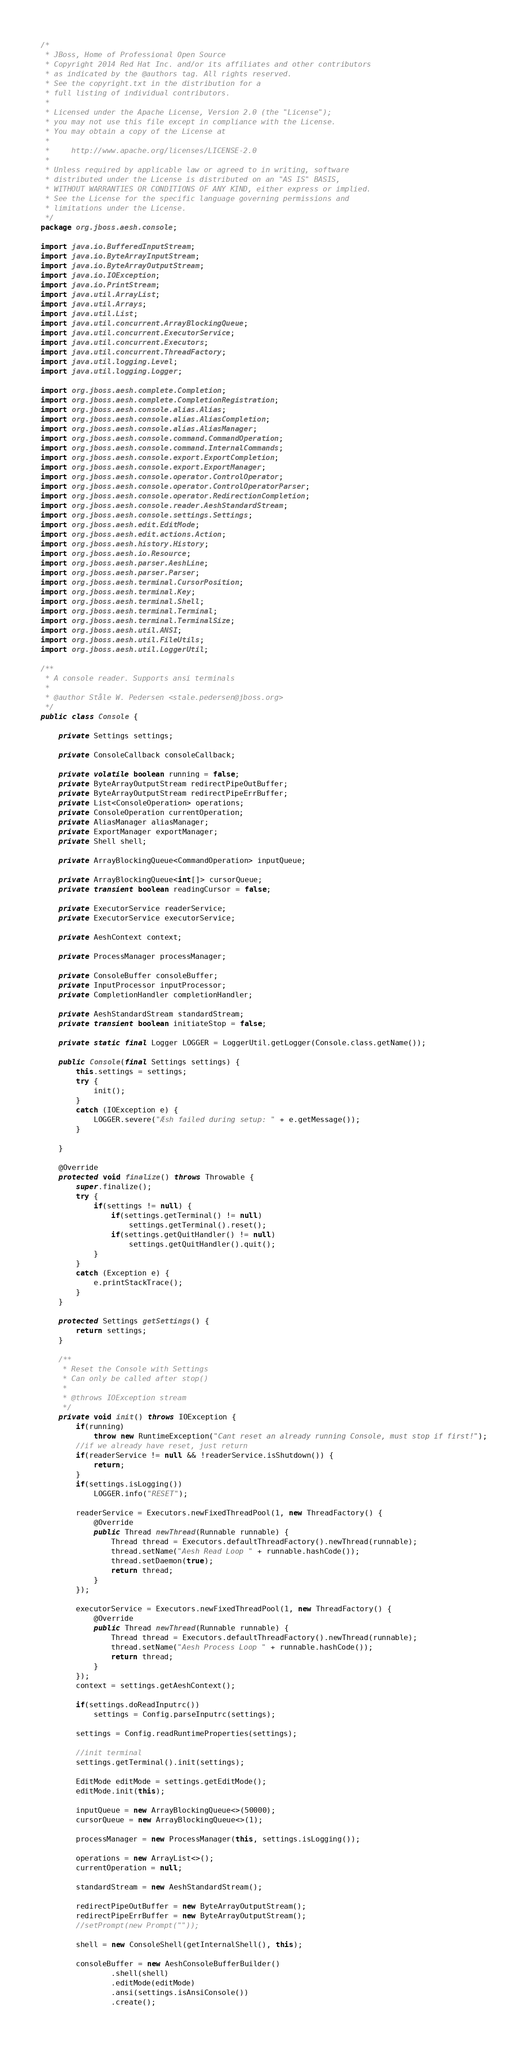<code> <loc_0><loc_0><loc_500><loc_500><_Java_>/*
 * JBoss, Home of Professional Open Source
 * Copyright 2014 Red Hat Inc. and/or its affiliates and other contributors
 * as indicated by the @authors tag. All rights reserved.
 * See the copyright.txt in the distribution for a
 * full listing of individual contributors.
 *
 * Licensed under the Apache License, Version 2.0 (the "License");
 * you may not use this file except in compliance with the License.
 * You may obtain a copy of the License at
 *
 *     http://www.apache.org/licenses/LICENSE-2.0
 *
 * Unless required by applicable law or agreed to in writing, software
 * distributed under the License is distributed on an "AS IS" BASIS,
 * WITHOUT WARRANTIES OR CONDITIONS OF ANY KIND, either express or implied.
 * See the License for the specific language governing permissions and
 * limitations under the License.
 */
package org.jboss.aesh.console;

import java.io.BufferedInputStream;
import java.io.ByteArrayInputStream;
import java.io.ByteArrayOutputStream;
import java.io.IOException;
import java.io.PrintStream;
import java.util.ArrayList;
import java.util.Arrays;
import java.util.List;
import java.util.concurrent.ArrayBlockingQueue;
import java.util.concurrent.ExecutorService;
import java.util.concurrent.Executors;
import java.util.concurrent.ThreadFactory;
import java.util.logging.Level;
import java.util.logging.Logger;

import org.jboss.aesh.complete.Completion;
import org.jboss.aesh.complete.CompletionRegistration;
import org.jboss.aesh.console.alias.Alias;
import org.jboss.aesh.console.alias.AliasCompletion;
import org.jboss.aesh.console.alias.AliasManager;
import org.jboss.aesh.console.command.CommandOperation;
import org.jboss.aesh.console.command.InternalCommands;
import org.jboss.aesh.console.export.ExportCompletion;
import org.jboss.aesh.console.export.ExportManager;
import org.jboss.aesh.console.operator.ControlOperator;
import org.jboss.aesh.console.operator.ControlOperatorParser;
import org.jboss.aesh.console.operator.RedirectionCompletion;
import org.jboss.aesh.console.reader.AeshStandardStream;
import org.jboss.aesh.console.settings.Settings;
import org.jboss.aesh.edit.EditMode;
import org.jboss.aesh.edit.actions.Action;
import org.jboss.aesh.history.History;
import org.jboss.aesh.io.Resource;
import org.jboss.aesh.parser.AeshLine;
import org.jboss.aesh.parser.Parser;
import org.jboss.aesh.terminal.CursorPosition;
import org.jboss.aesh.terminal.Key;
import org.jboss.aesh.terminal.Shell;
import org.jboss.aesh.terminal.Terminal;
import org.jboss.aesh.terminal.TerminalSize;
import org.jboss.aesh.util.ANSI;
import org.jboss.aesh.util.FileUtils;
import org.jboss.aesh.util.LoggerUtil;

/**
 * A console reader. Supports ansi terminals
 *
 * @author Ståle W. Pedersen <stale.pedersen@jboss.org>
 */
public class Console {

    private Settings settings;

    private ConsoleCallback consoleCallback;

    private volatile boolean running = false;
    private ByteArrayOutputStream redirectPipeOutBuffer;
    private ByteArrayOutputStream redirectPipeErrBuffer;
    private List<ConsoleOperation> operations;
    private ConsoleOperation currentOperation;
    private AliasManager aliasManager;
    private ExportManager exportManager;
    private Shell shell;

    private ArrayBlockingQueue<CommandOperation> inputQueue;

    private ArrayBlockingQueue<int[]> cursorQueue;
    private transient boolean readingCursor = false;

    private ExecutorService readerService;
    private ExecutorService executorService;

    private AeshContext context;

    private ProcessManager processManager;

    private ConsoleBuffer consoleBuffer;
    private InputProcessor inputProcessor;
    private CompletionHandler completionHandler;

    private AeshStandardStream standardStream;
    private transient boolean initiateStop = false;

    private static final Logger LOGGER = LoggerUtil.getLogger(Console.class.getName());

    public Console(final Settings settings) {
        this.settings = settings;
        try {
            init();
        }
        catch (IOException e) {
            LOGGER.severe("Æsh failed during setup: " + e.getMessage());
        }

    }

    @Override
    protected void finalize() throws Throwable {
        super.finalize();
        try {
            if(settings != null) {
                if(settings.getTerminal() != null)
                    settings.getTerminal().reset();
                if(settings.getQuitHandler() != null)
                    settings.getQuitHandler().quit();
            }
        }
        catch (Exception e) {
            e.printStackTrace();
        }
    }

    protected Settings getSettings() {
        return settings;
    }

    /**
     * Reset the Console with Settings
     * Can only be called after stop()
     *
     * @throws IOException stream
     */
    private void init() throws IOException {
        if(running)
            throw new RuntimeException("Cant reset an already running Console, must stop if first!");
        //if we already have reset, just return
        if(readerService != null && !readerService.isShutdown()) {
            return;
        }
        if(settings.isLogging())
            LOGGER.info("RESET");

        readerService = Executors.newFixedThreadPool(1, new ThreadFactory() {
            @Override
            public Thread newThread(Runnable runnable) {
                Thread thread = Executors.defaultThreadFactory().newThread(runnable);
                thread.setName("Aesh Read Loop " + runnable.hashCode());
                thread.setDaemon(true);
                return thread;
            }
        });

        executorService = Executors.newFixedThreadPool(1, new ThreadFactory() {
            @Override
            public Thread newThread(Runnable runnable) {
                Thread thread = Executors.defaultThreadFactory().newThread(runnable);
                thread.setName("Aesh Process Loop " + runnable.hashCode());
                return thread;
            }
        });
        context = settings.getAeshContext();

        if(settings.doReadInputrc())
            settings = Config.parseInputrc(settings);

        settings = Config.readRuntimeProperties(settings);

        //init terminal
        settings.getTerminal().init(settings);

        EditMode editMode = settings.getEditMode();
        editMode.init(this);

        inputQueue = new ArrayBlockingQueue<>(50000);
        cursorQueue = new ArrayBlockingQueue<>(1);

        processManager = new ProcessManager(this, settings.isLogging());

        operations = new ArrayList<>();
        currentOperation = null;

        standardStream = new AeshStandardStream();

        redirectPipeOutBuffer = new ByteArrayOutputStream();
        redirectPipeErrBuffer = new ByteArrayOutputStream();
        //setPrompt(new Prompt(""));

        shell = new ConsoleShell(getInternalShell(), this);

        consoleBuffer = new AeshConsoleBufferBuilder()
                .shell(shell)
                .editMode(editMode)
                .ansi(settings.isAnsiConsole())
                .create();
</code> 